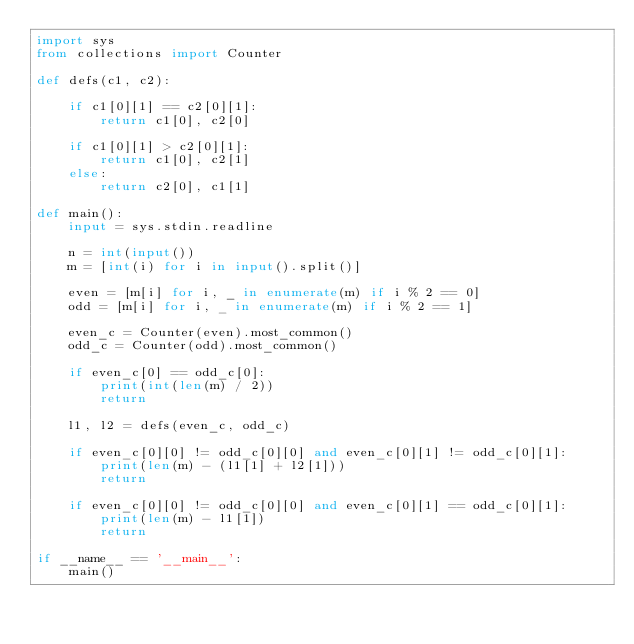Convert code to text. <code><loc_0><loc_0><loc_500><loc_500><_Python_>import sys
from collections import Counter

def defs(c1, c2):
    
    if c1[0][1] == c2[0][1]:
        return c1[0], c2[0]
    
    if c1[0][1] > c2[0][1]:
        return c1[0], c2[1]
    else:
        return c2[0], c1[1]

def main():
    input = sys.stdin.readline
    
    n = int(input())
    m = [int(i) for i in input().split()]
    
    even = [m[i] for i, _ in enumerate(m) if i % 2 == 0]
    odd = [m[i] for i, _ in enumerate(m) if i % 2 == 1]
    
    even_c = Counter(even).most_common()
    odd_c = Counter(odd).most_common()
    
    if even_c[0] == odd_c[0]:
        print(int(len(m) / 2))
        return
    
    l1, l2 = defs(even_c, odd_c)
    
    if even_c[0][0] != odd_c[0][0] and even_c[0][1] != odd_c[0][1]:
        print(len(m) - (l1[1] + l2[1]))
        return
    
    if even_c[0][0] != odd_c[0][0] and even_c[0][1] == odd_c[0][1]:
        print(len(m) - l1[1])
        return

if __name__ == '__main__':
    main()
    
</code> 